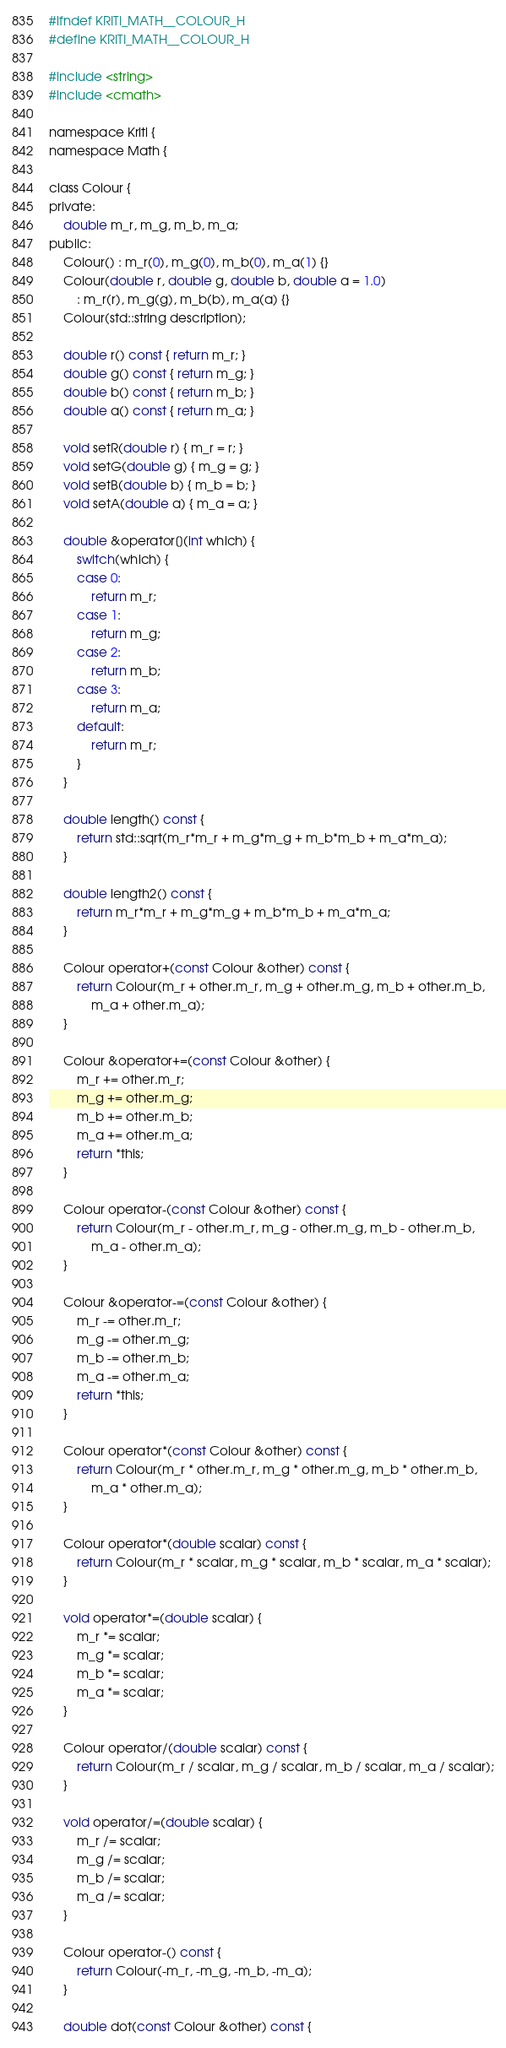<code> <loc_0><loc_0><loc_500><loc_500><_C_>#ifndef KRITI_MATH__COLOUR_H
#define KRITI_MATH__COLOUR_H

#include <string>
#include <cmath>

namespace Kriti {
namespace Math {

class Colour {
private:
    double m_r, m_g, m_b, m_a;
public:
    Colour() : m_r(0), m_g(0), m_b(0), m_a(1) {}
    Colour(double r, double g, double b, double a = 1.0)
        : m_r(r), m_g(g), m_b(b), m_a(a) {}
    Colour(std::string description);

    double r() const { return m_r; }
    double g() const { return m_g; }
    double b() const { return m_b; }
    double a() const { return m_a; }

    void setR(double r) { m_r = r; }
    void setG(double g) { m_g = g; }
    void setB(double b) { m_b = b; }
    void setA(double a) { m_a = a; }

    double &operator[](int which) {
        switch(which) {
        case 0:
            return m_r;
        case 1:
            return m_g;
        case 2:
            return m_b;
        case 3:
            return m_a;
        default:
            return m_r;
        }
    }

    double length() const {
        return std::sqrt(m_r*m_r + m_g*m_g + m_b*m_b + m_a*m_a);
    }

    double length2() const {
        return m_r*m_r + m_g*m_g + m_b*m_b + m_a*m_a;
    }

    Colour operator+(const Colour &other) const {
        return Colour(m_r + other.m_r, m_g + other.m_g, m_b + other.m_b,
            m_a + other.m_a);
    }

    Colour &operator+=(const Colour &other) {
        m_r += other.m_r;
        m_g += other.m_g;
        m_b += other.m_b;
        m_a += other.m_a;
        return *this;
    }

    Colour operator-(const Colour &other) const {
        return Colour(m_r - other.m_r, m_g - other.m_g, m_b - other.m_b,
            m_a - other.m_a);
    }

    Colour &operator-=(const Colour &other) {
        m_r -= other.m_r;
        m_g -= other.m_g;
        m_b -= other.m_b;
        m_a -= other.m_a;
        return *this;
    }

    Colour operator*(const Colour &other) const {
        return Colour(m_r * other.m_r, m_g * other.m_g, m_b * other.m_b,
            m_a * other.m_a);
    }

    Colour operator*(double scalar) const {
        return Colour(m_r * scalar, m_g * scalar, m_b * scalar, m_a * scalar);
    }

    void operator*=(double scalar) {
        m_r *= scalar;
        m_g *= scalar;
        m_b *= scalar;
        m_a *= scalar;
    }

    Colour operator/(double scalar) const {
        return Colour(m_r / scalar, m_g / scalar, m_b / scalar, m_a / scalar);
    }

    void operator/=(double scalar) {
        m_r /= scalar;
        m_g /= scalar;
        m_b /= scalar;
        m_a /= scalar;
    }

    Colour operator-() const {
        return Colour(-m_r, -m_g, -m_b, -m_a);
    }

    double dot(const Colour &other) const {</code> 